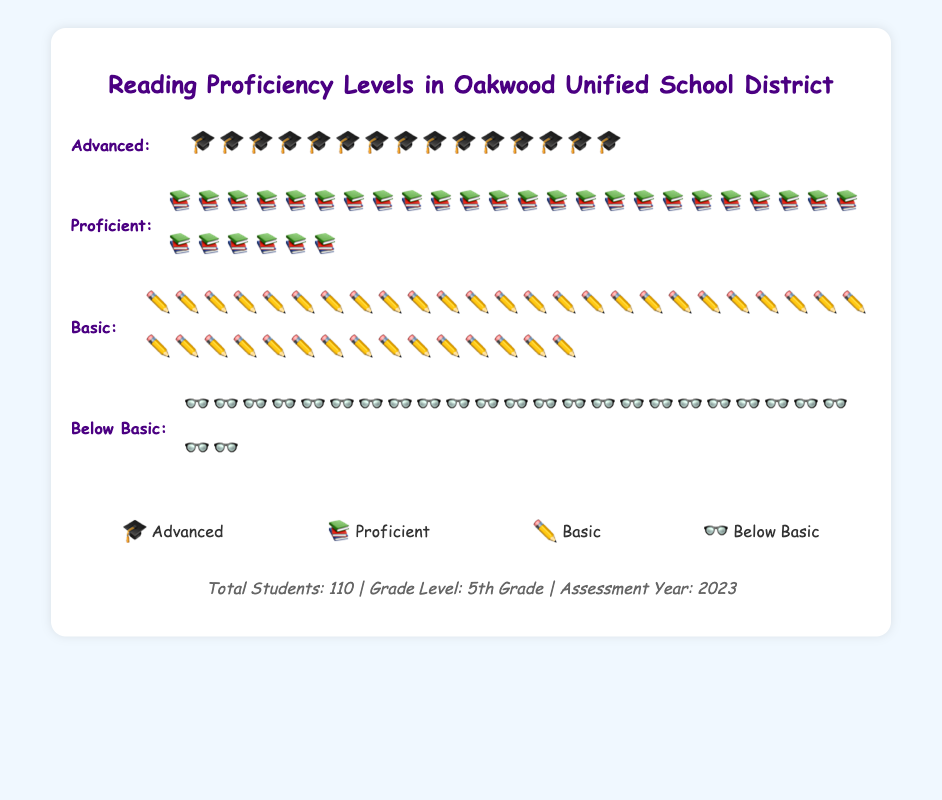What is the title of the figure? The title is located at the top of the figure and indicates the main subject. It helps the viewer know what the figure is about.
Answer: Reading Proficiency Levels in Oakwood Unified School District How many students are at the "Advanced" level? The "Advanced" level is marked with mortarboard caps (🎓). Counting these icons gives the number of students at this level.
Answer: 15 Which level has the most students? By counting the icons in each level, we determine the "Basic" level, represented by pencils (✏️), has the most students.
Answer: Basic What is the total number of students at the "Proficient" and "Below Basic" levels combined? Summing the students in the "Proficient" level (30) and the "Below Basic" level (25) gives the total. 30 + 25 = 55
Answer: 55 How many students are not at the "Basic" level? First, find the total number of students, then subtract those at the "Basic" level. 110 - 40 = 70
Answer: 70 If another student advanced to "Advanced," how many would be at that level? Adding one to the current number of "Advanced" students (15) results in 15 + 1 = 16
Answer: 16 Which level has more students: "Below Basic" or "Advanced"? Comparing the counts of "Below Basic" (25) and "Advanced" (15) levels shows "Below Basic" has more students.
Answer: Below Basic What percentage of students are at the "Basic" level? Dividing the "Basic" students by the total and multiplying by 100 gives the percentage. (40 / 110) * 100 ≈ 36.36%
Answer: 36.36% How many more students are in the "Proficient" level compared to the "Advanced" level? Subtracting the "Advanced" students from the "Proficient" students gives the difference. 30 - 15 = 15
Answer: 15 What icons represent each reading proficiency level? The legend at the bottom of the figure denotes the icons for each level: 🎓 for Advanced, 📚 for Proficient, ✏️ for Basic, and 👓 for Below Basic.
Answer: 🎓, 📚, ✏️, 👓 